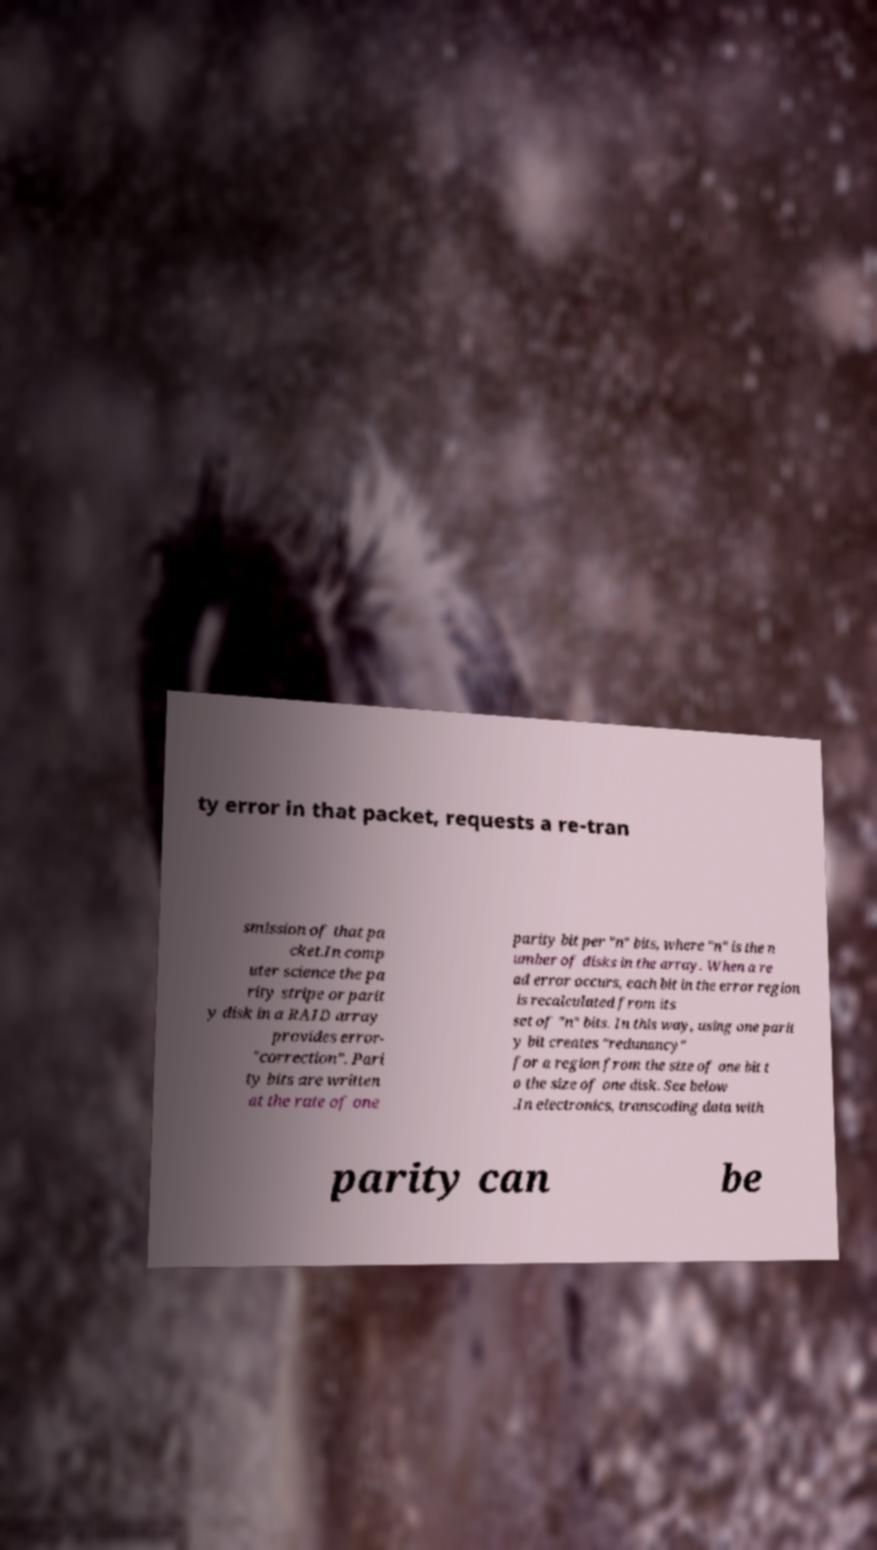Could you extract and type out the text from this image? ty error in that packet, requests a re-tran smission of that pa cket.In comp uter science the pa rity stripe or parit y disk in a RAID array provides error- "correction". Pari ty bits are written at the rate of one parity bit per "n" bits, where "n" is the n umber of disks in the array. When a re ad error occurs, each bit in the error region is recalculated from its set of "n" bits. In this way, using one parit y bit creates "redunancy" for a region from the size of one bit t o the size of one disk. See below .In electronics, transcoding data with parity can be 